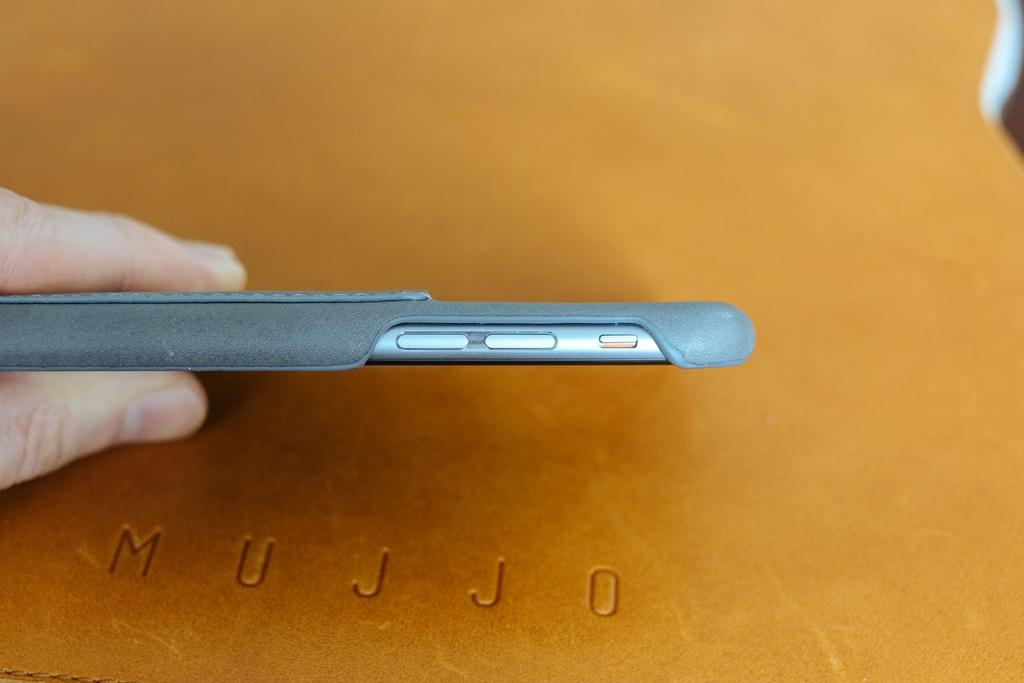What is engraved on the table?
Make the answer very short. Mujjo. 